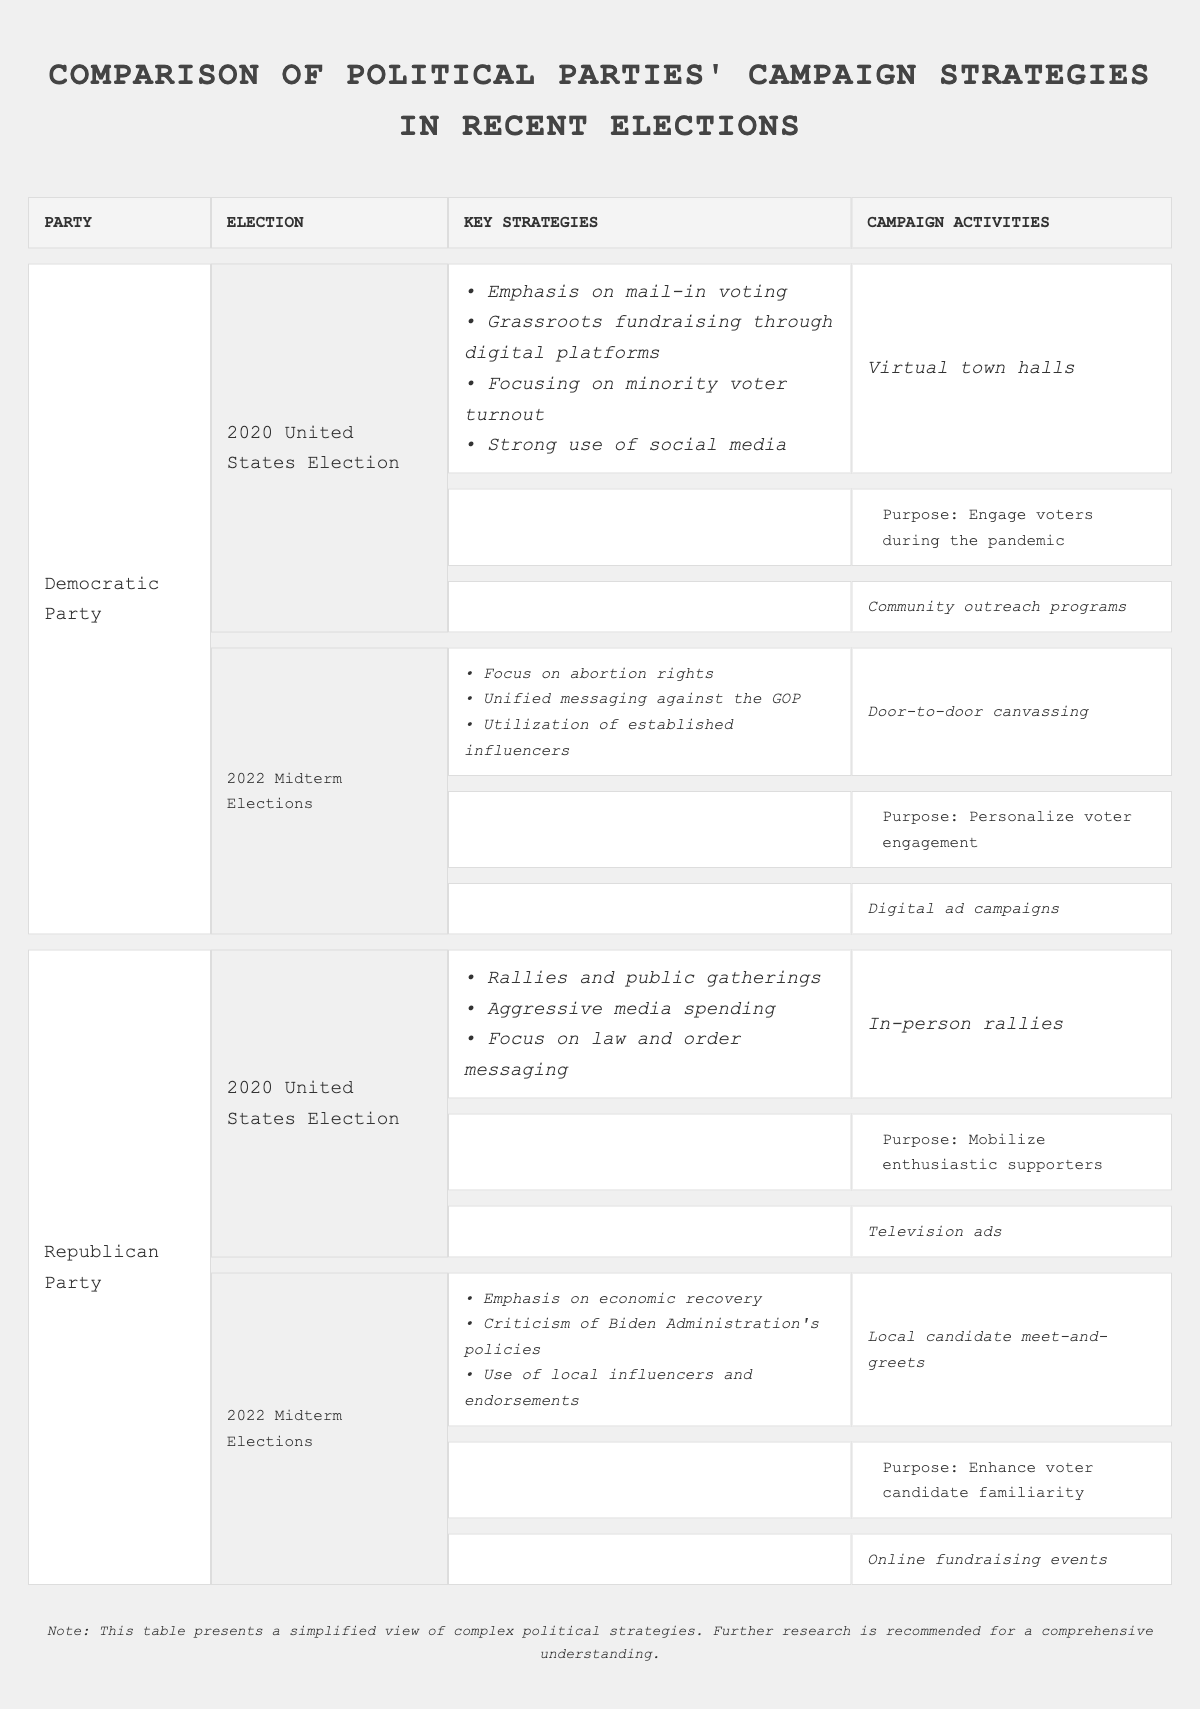What key strategy did the Democratic Party emphasize in the 2020 United States Election? The table shows that the Democratic Party's key strategies for the 2020 United States Election included "Emphasis on mail-in voting."
Answer: Emphasis on mail-in voting Which political party focused on law and order messaging during the 2020 United States Election? According to the table, the Republican Party listed "Focus on law and order messaging" as one of their key strategies for the 2020 election.
Answer: Republican Party Did the Democratic Party utilize online fundraising events in the 2022 Midterm Elections? The campaign activities for the Democratic Party in the 2022 Midterm Elections do not include "Online fundraising events," suggesting they did not utilize that method.
Answer: No What was the primary purpose of the virtual town halls organized by the Democratic Party during the 2020 United States Election? The table indicates that the purpose of virtual town halls was "Engage voters during the pandemic," demonstrating their aim to connect with voters in a safe manner.
Answer: Engage voters during the pandemic What combined strategies did the Republican Party emphasize in the 2022 Midterm Elections? The Republican Party's strategies for the 2022 Midterm Elections include "Emphasis on economic recovery," "Criticism of Biden Administration's policies," and "Use of local influencers and endorsements." This shows their focus on economic issues and leveraging local support.
Answer: Emphasis on economic recovery, Criticism of Biden Administration's policies, Use of local influencers and endorsements How many unique key strategies did the Democratic Party use across both elections? The Democratic Party had a total of 7 unique key strategies (4 in 2020 and 3 in 2022), which do not overlap. Thus, you sum them up to find the unique count across both elections.
Answer: 7 In the 2022 Midterm Elections, which activities were employed by the Republican Party? During the 2022 Midterm Elections, the Republican Party engaged in "Local candidate meet-and-greets" and "Online fundraising events." Both activities were focused on enhancing familiarity with candidates and engaging donors.
Answer: Local candidate meet-and-greets, Online fundraising events Was community outreach a campaign activity for the Republican Party in the 2022 Midterm Elections? The campaign activities listed for the Republican Party in the 2022 Midterm Elections do not include community outreach programs, so the answer is no.
Answer: No Explain the differences between the campaign activities of the two parties in the 2020 United States Election. The Democratic Party focused on virtual town halls and community outreach, which are conducive to voter engagement during the pandemic. In contrast, the Republican Party emphasized in-person rallies and television ads to reach a wider audience. This shows a contrasting approach to voter engagement during a crucial time.
Answer: Democratic Party focused on virtual engagement; Republican Party focused on in-person mobilization 